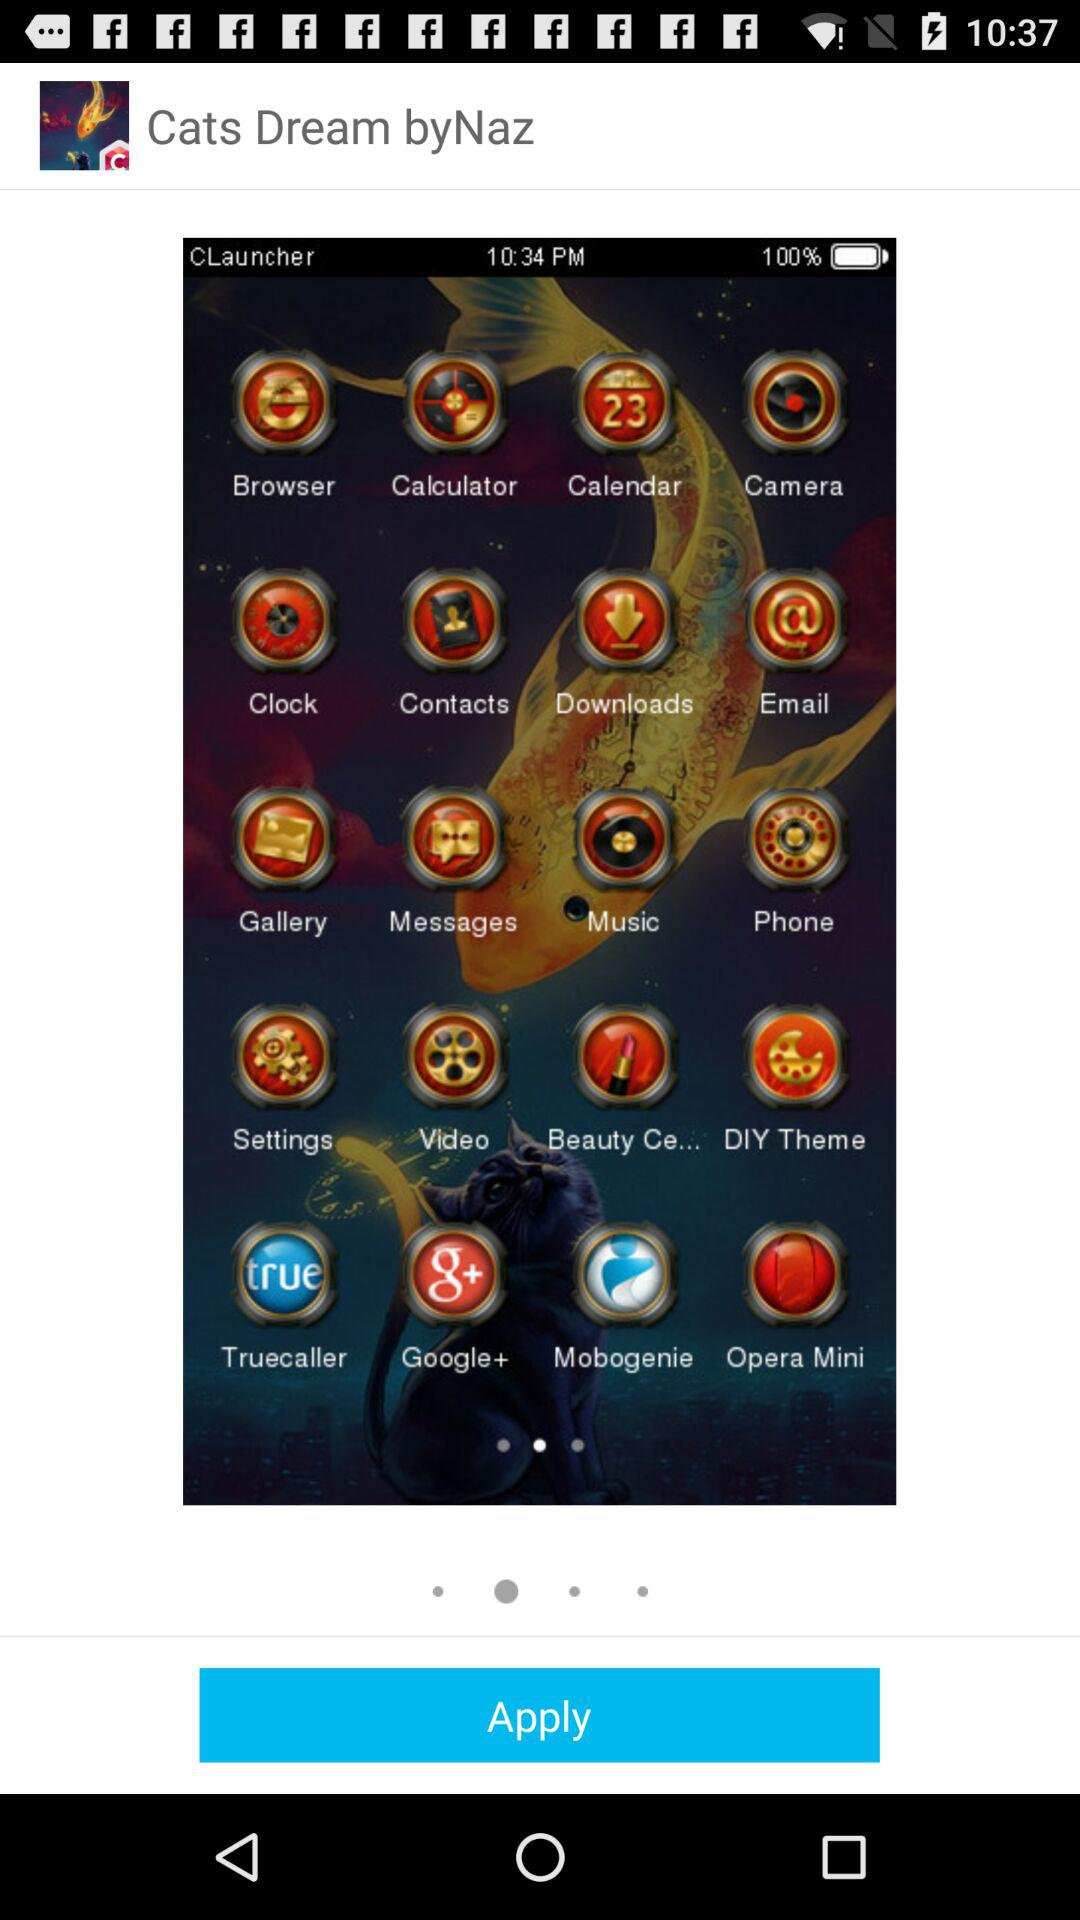What is the application name? The application name is "Cats Dream byNaz". 